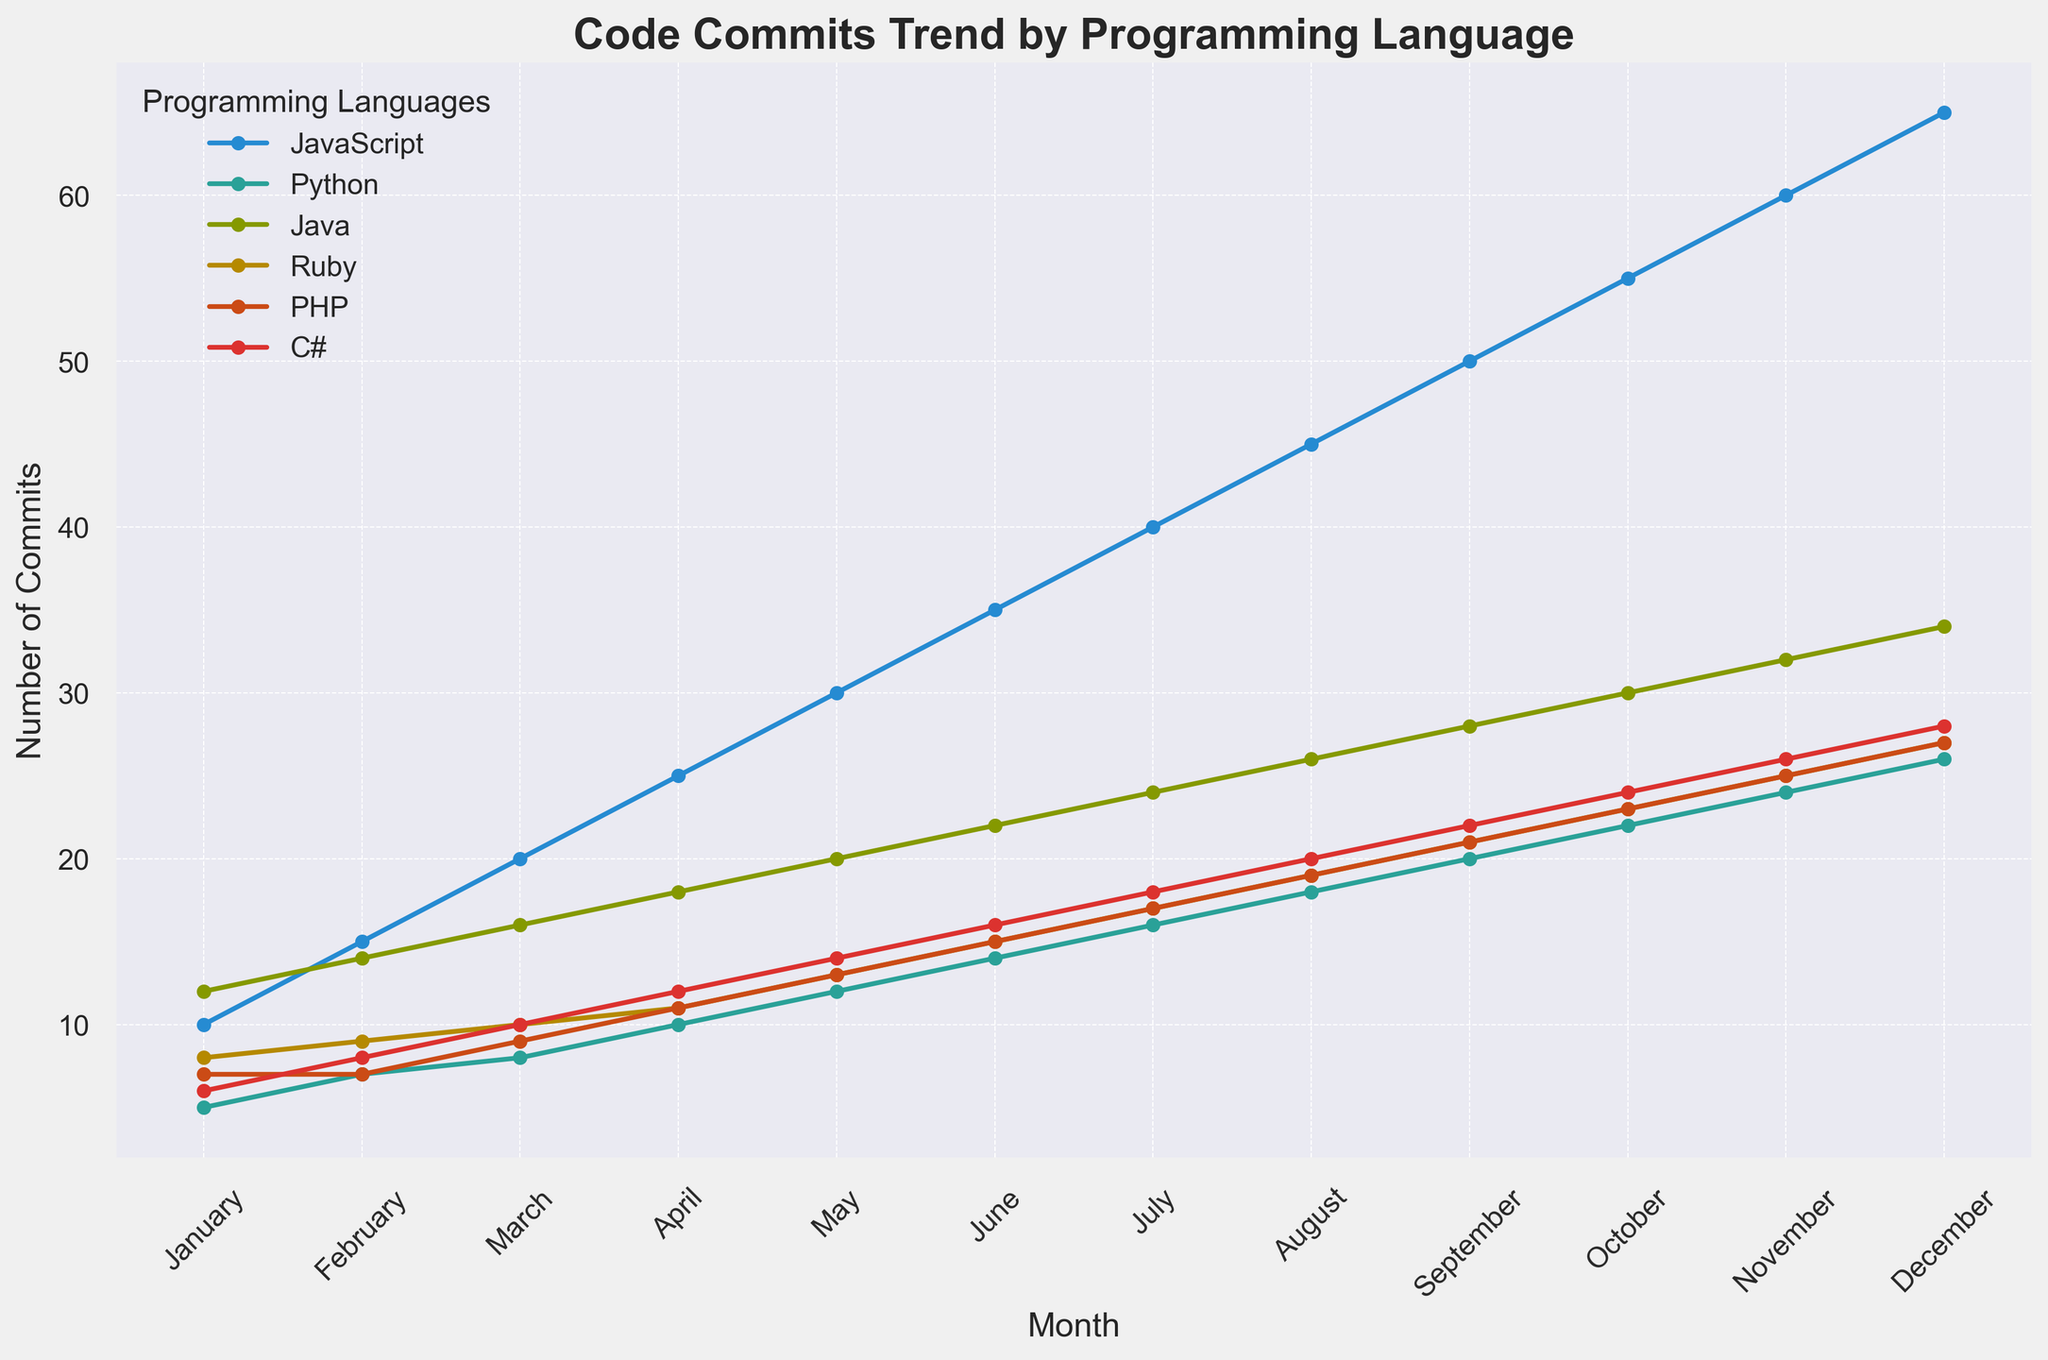Which month had the highest number of JavaScript commits? To find this, look for the highest point on the JavaScript line in the chart. According to the data, December had the highest number of JavaScript commits.
Answer: December Which programming language had the least number of commits in April? Look for the lowest point among all the lines for April. Based on the data, PHP had the least number of commits in April.
Answer: PHP How many more commits were done in Java in October compared to Java in January? Locate the points corresponding to Java in October and January, then subtract the January value from the October value (30 - 12).
Answer: 18 Which two programming languages showed the most similar trend in commit numbers throughout the year? Visually analyze the lines on the plot to see which ones follow a similar trend or pattern across all months. In this case, Python and Ruby show a similar trend.
Answer: Python and Ruby What is the average number of commits for PHP over the year? Sum the PHP commits for all months and divide by the number of months: (7+7+9+11+13+15+17+19+21+23+25+27)/12. The calculation yields 17.
Answer: 17 Between May and August, which programming language had the highest increase in commits? Determine the difference in commits for each language between May and August: 
JavaScript (45-30 = 15), Python (18-12 = 6), Java (26-20 = 6), Ruby (19-13 = 6), PHP (19-13 = 6), C# (20-14 = 6). JavaScript has the highest increase.
Answer: JavaScript Which month had the largest total number of commits across all programming languages combined? Sum the commits for each month and compare:
January (10+5+12+8+7+6=48), 
February (15+7+14+9+7+8=60), 
March (20+8+16+10+9+10=73), 
April (25+10+18+11+11+12=87), 
May (30+12+20+13+13+14=102), 
June (35+14+22+15+15+16=117), 
July (40+16+24+17+17+18=132), 
August (45+18+26+19+19+20=147), 
September (50+20+28+21+21+22=162), 
October (55+22+30+23+23+24=177), 
November (60+24+32+25+25+26=192), 
December (65+26+34+27+27+28=207). December has the largest total.
Answer: December How does the trend of Python commits compare to that of C# over the year? Visually analyze the two lines for Python and C# in the plot to see how they rise or fall over the months. Python follows a steady increasing trend similar to C#, with both showing consistent monthly increments.
Answer: Similar steady increase Was there any month where all programming languages had the same number of commits? Review each month's data points to see if the values match across all languages. No month had the same number of commits for all languages.
Answer: No How many commits in total were made in November across all programming languages? Sum the number of commits across all programming languages for the month of November: 60 + 24 + 32 + 25 + 25 + 26 = 192.
Answer: 192 